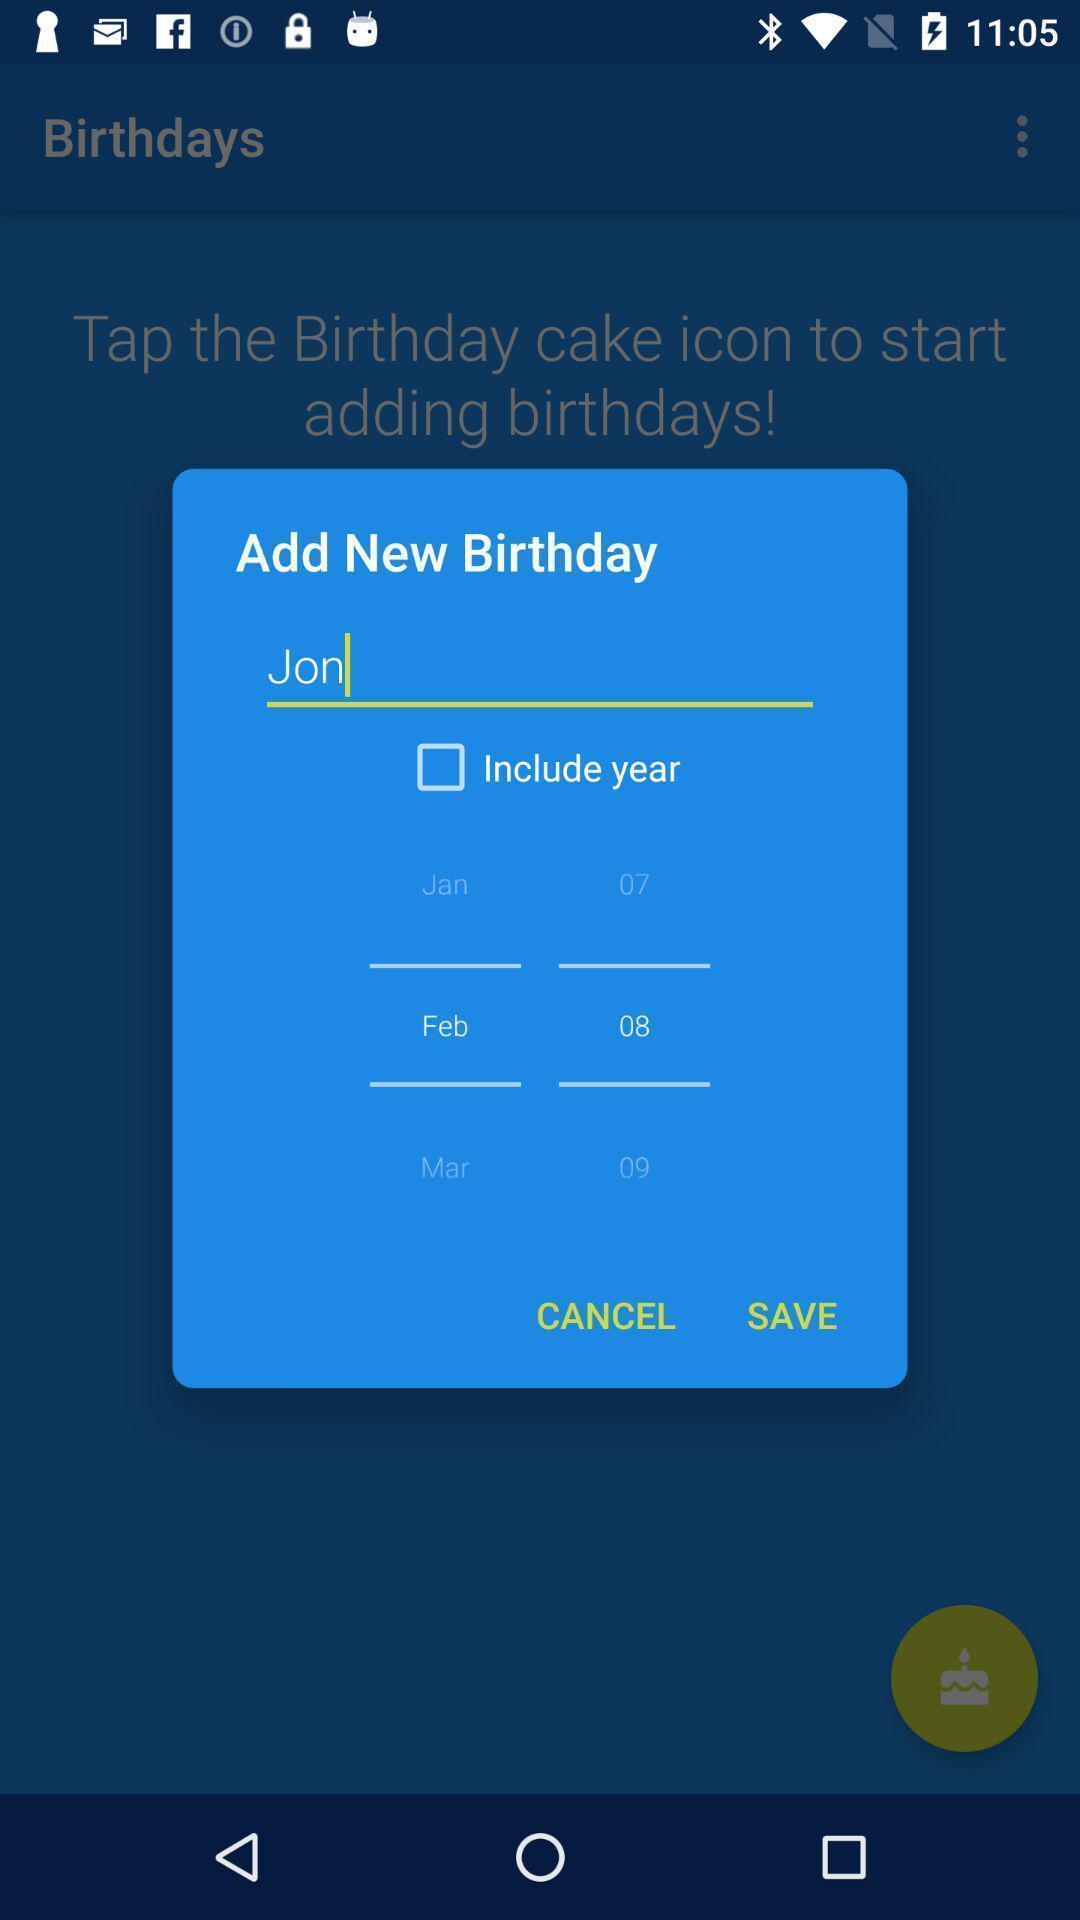Please provide a description for this image. Pop-up to add new birthday for a reminder. 